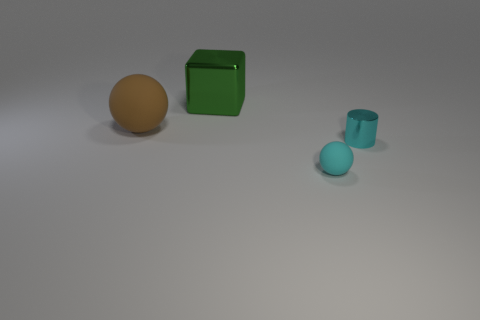Add 3 rubber objects. How many objects exist? 7 Subtract all brown balls. How many balls are left? 1 Subtract all cubes. How many objects are left? 3 Add 3 large things. How many large things exist? 5 Subtract 1 cyan cylinders. How many objects are left? 3 Subtract 1 cubes. How many cubes are left? 0 Subtract all cyan balls. Subtract all gray cylinders. How many balls are left? 1 Subtract all tiny cylinders. Subtract all cyan things. How many objects are left? 1 Add 1 cubes. How many cubes are left? 2 